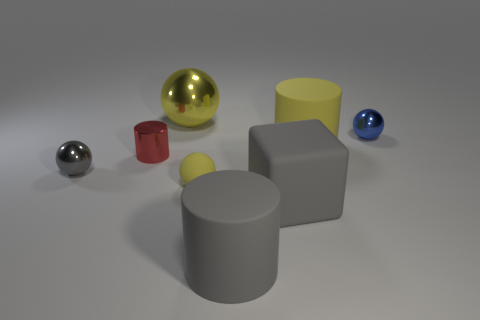How many red objects are either rubber spheres or spheres?
Give a very brief answer. 0. What number of other objects are the same material as the blue sphere?
Your response must be concise. 3. Do the big rubber object that is behind the small gray ball and the tiny red thing have the same shape?
Give a very brief answer. Yes. Are there any big rubber cubes?
Make the answer very short. Yes. Is there any other thing that is the same shape as the small yellow thing?
Your answer should be very brief. Yes. Are there more matte cylinders that are behind the large yellow shiny ball than tiny blue matte blocks?
Give a very brief answer. No. Are there any small matte balls behind the metallic cylinder?
Keep it short and to the point. No. Do the gray block and the red metal cylinder have the same size?
Keep it short and to the point. No. What size is the yellow shiny thing that is the same shape as the small blue object?
Make the answer very short. Large. There is a large yellow thing that is behind the tiny metal object that is behind the red object; what is its material?
Offer a very short reply. Metal. 